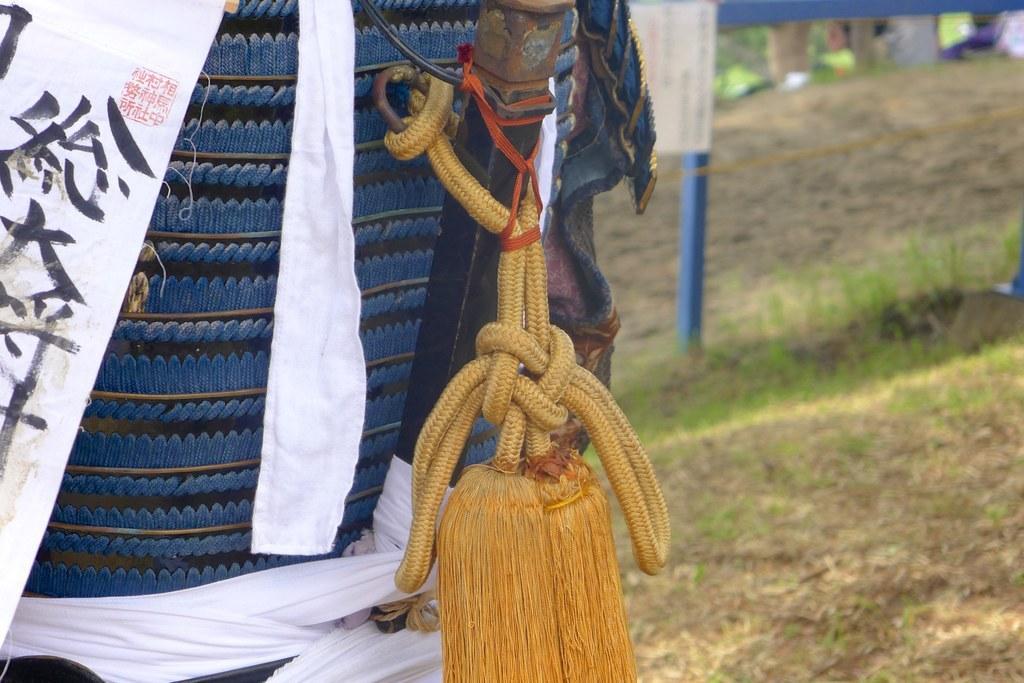How would you summarize this image in a sentence or two? In this picture I can see something written on a white color object. Here I can see something is tied with some object. In the background, I can see grass and a pole. 